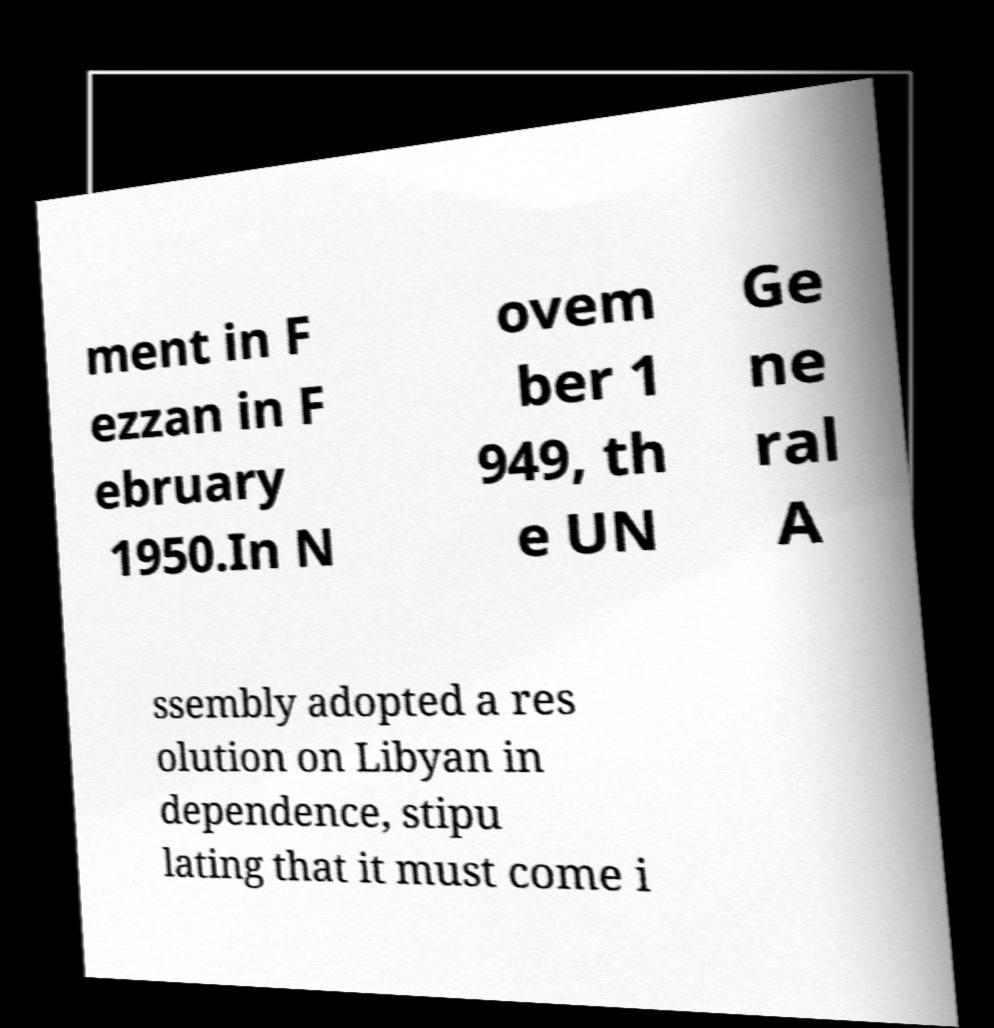Can you accurately transcribe the text from the provided image for me? ment in F ezzan in F ebruary 1950.In N ovem ber 1 949, th e UN Ge ne ral A ssembly adopted a res olution on Libyan in dependence, stipu lating that it must come i 